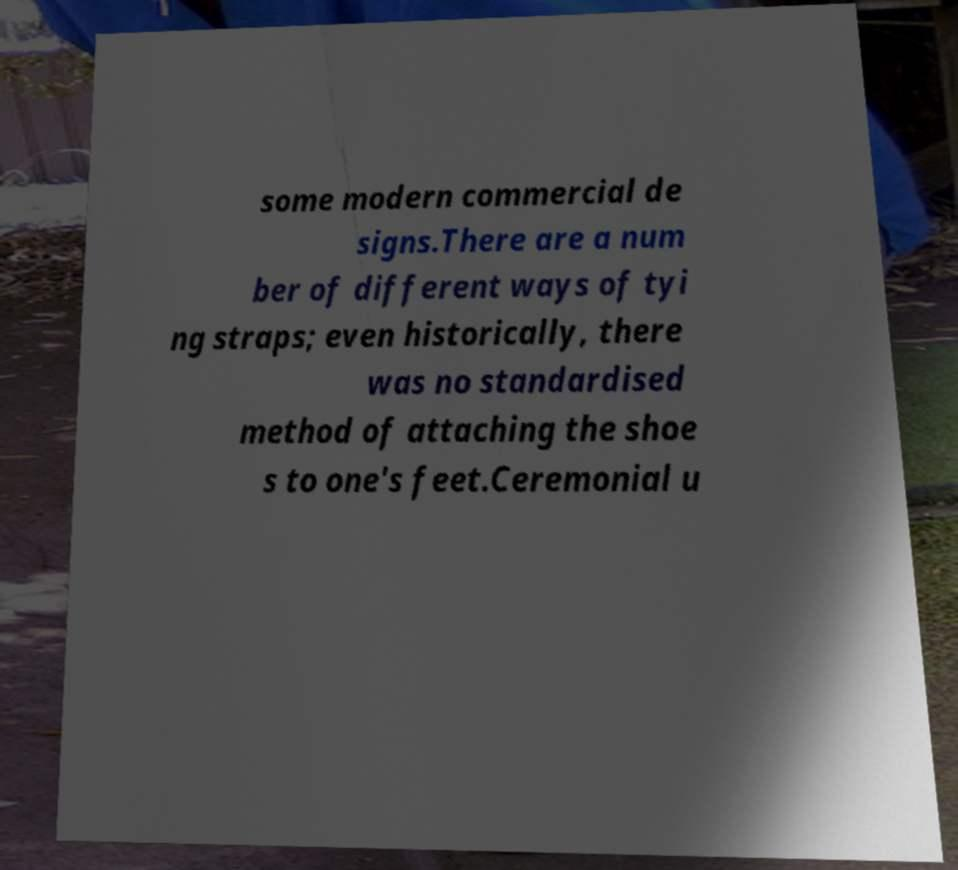Please read and relay the text visible in this image. What does it say? some modern commercial de signs.There are a num ber of different ways of tyi ng straps; even historically, there was no standardised method of attaching the shoe s to one's feet.Ceremonial u 